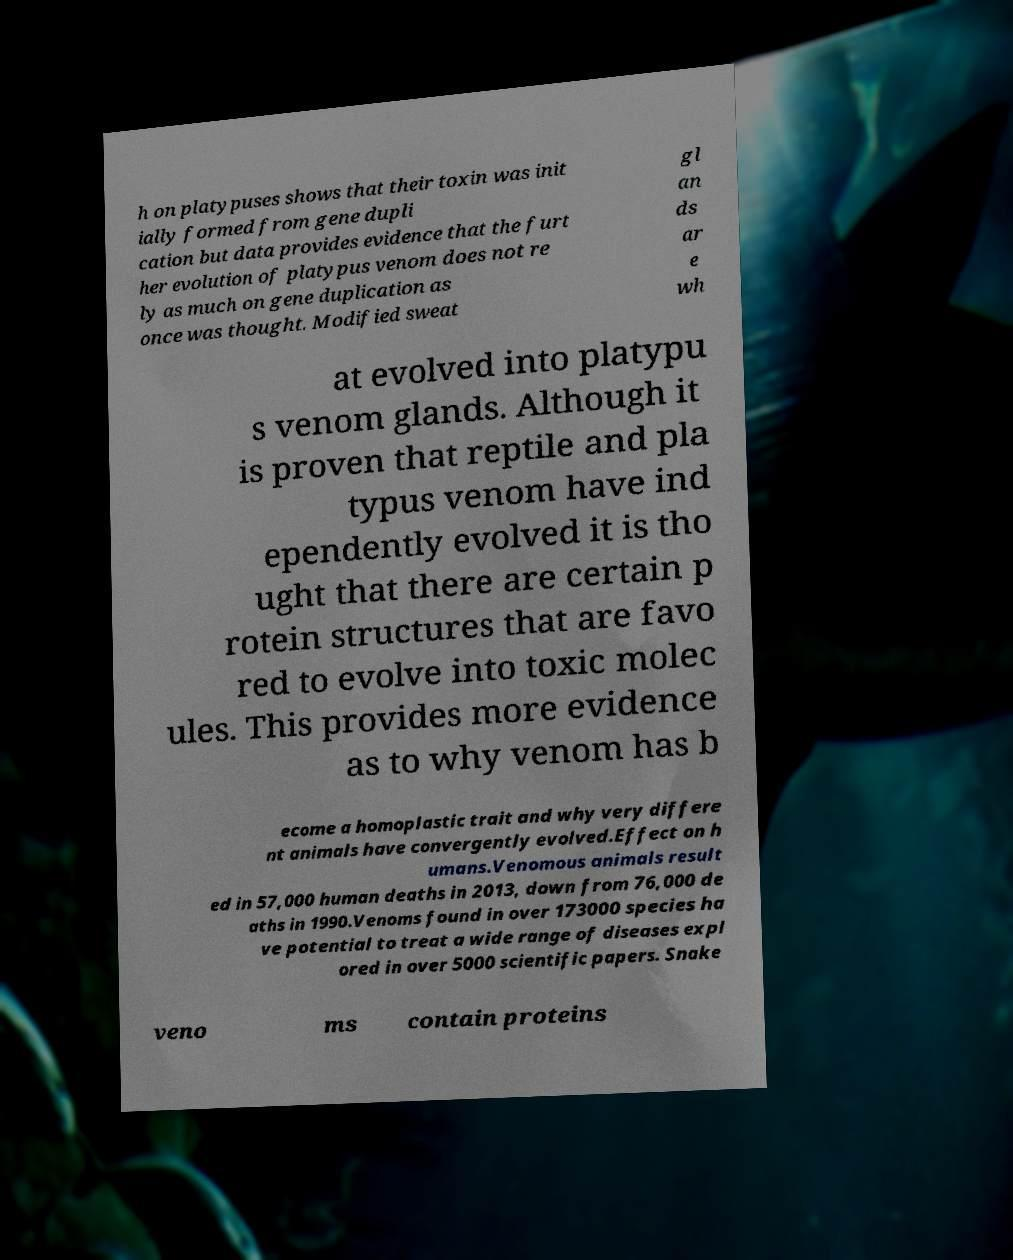There's text embedded in this image that I need extracted. Can you transcribe it verbatim? h on platypuses shows that their toxin was init ially formed from gene dupli cation but data provides evidence that the furt her evolution of platypus venom does not re ly as much on gene duplication as once was thought. Modified sweat gl an ds ar e wh at evolved into platypu s venom glands. Although it is proven that reptile and pla typus venom have ind ependently evolved it is tho ught that there are certain p rotein structures that are favo red to evolve into toxic molec ules. This provides more evidence as to why venom has b ecome a homoplastic trait and why very differe nt animals have convergently evolved.Effect on h umans.Venomous animals result ed in 57,000 human deaths in 2013, down from 76,000 de aths in 1990.Venoms found in over 173000 species ha ve potential to treat a wide range of diseases expl ored in over 5000 scientific papers. Snake veno ms contain proteins 